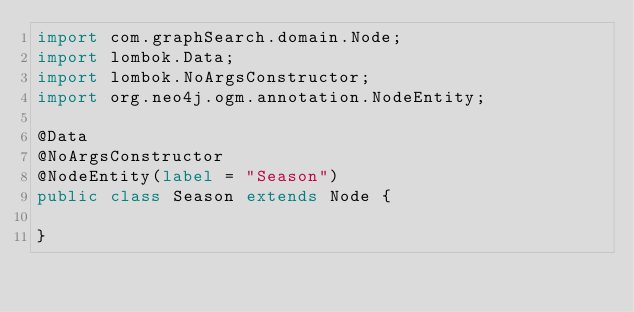Convert code to text. <code><loc_0><loc_0><loc_500><loc_500><_Java_>import com.graphSearch.domain.Node;
import lombok.Data;
import lombok.NoArgsConstructor;
import org.neo4j.ogm.annotation.NodeEntity;

@Data
@NoArgsConstructor
@NodeEntity(label = "Season")
public class Season extends Node {

}
</code> 